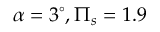<formula> <loc_0><loc_0><loc_500><loc_500>\alpha = 3 ^ { \circ } , \Pi _ { s } = 1 . 9</formula> 